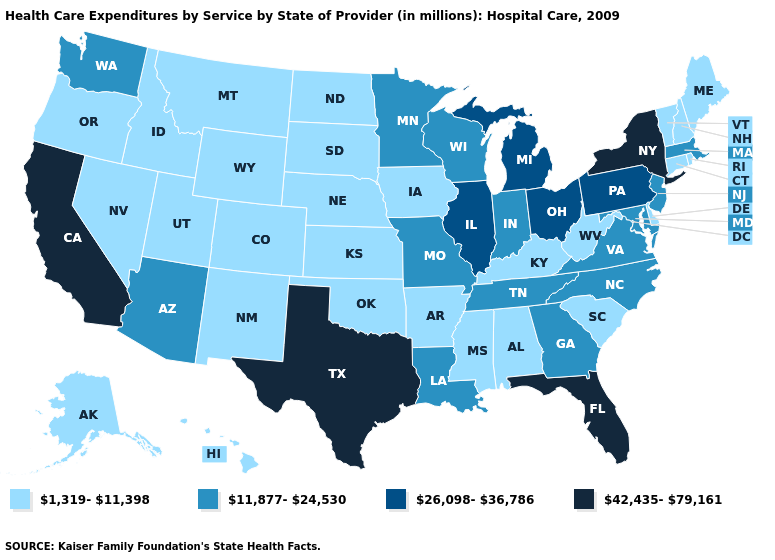Which states have the lowest value in the MidWest?
Quick response, please. Iowa, Kansas, Nebraska, North Dakota, South Dakota. What is the highest value in the West ?
Be succinct. 42,435-79,161. Does Hawaii have the lowest value in the USA?
Short answer required. Yes. Name the states that have a value in the range 42,435-79,161?
Give a very brief answer. California, Florida, New York, Texas. Does Kansas have a lower value than Colorado?
Write a very short answer. No. What is the value of Montana?
Keep it brief. 1,319-11,398. Name the states that have a value in the range 26,098-36,786?
Answer briefly. Illinois, Michigan, Ohio, Pennsylvania. What is the value of Nebraska?
Keep it brief. 1,319-11,398. Does Washington have a lower value than Illinois?
Give a very brief answer. Yes. Which states have the highest value in the USA?
Short answer required. California, Florida, New York, Texas. Name the states that have a value in the range 42,435-79,161?
Short answer required. California, Florida, New York, Texas. What is the value of Indiana?
Write a very short answer. 11,877-24,530. What is the value of Mississippi?
Concise answer only. 1,319-11,398. Does the first symbol in the legend represent the smallest category?
Short answer required. Yes. What is the value of North Dakota?
Short answer required. 1,319-11,398. 